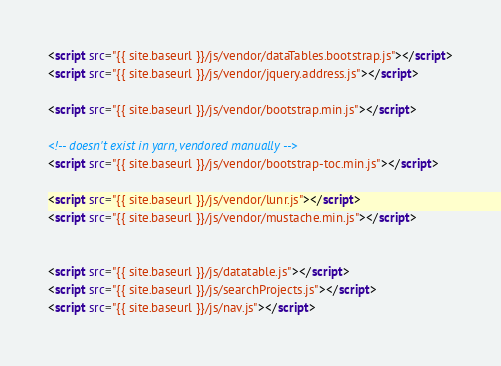<code> <loc_0><loc_0><loc_500><loc_500><_HTML_><script src="{{ site.baseurl }}/js/vendor/dataTables.bootstrap.js"></script>
<script src="{{ site.baseurl }}/js/vendor/jquery.address.js"></script>

<script src="{{ site.baseurl }}/js/vendor/bootstrap.min.js"></script>

<!-- doesn't exist in yarn, vendored manually -->
<script src="{{ site.baseurl }}/js/vendor/bootstrap-toc.min.js"></script>

<script src="{{ site.baseurl }}/js/vendor/lunr.js"></script>
<script src="{{ site.baseurl }}/js/vendor/mustache.min.js"></script>


<script src="{{ site.baseurl }}/js/datatable.js"></script>
<script src="{{ site.baseurl }}/js/searchProjects.js"></script>
<script src="{{ site.baseurl }}/js/nav.js"></script>
</code> 